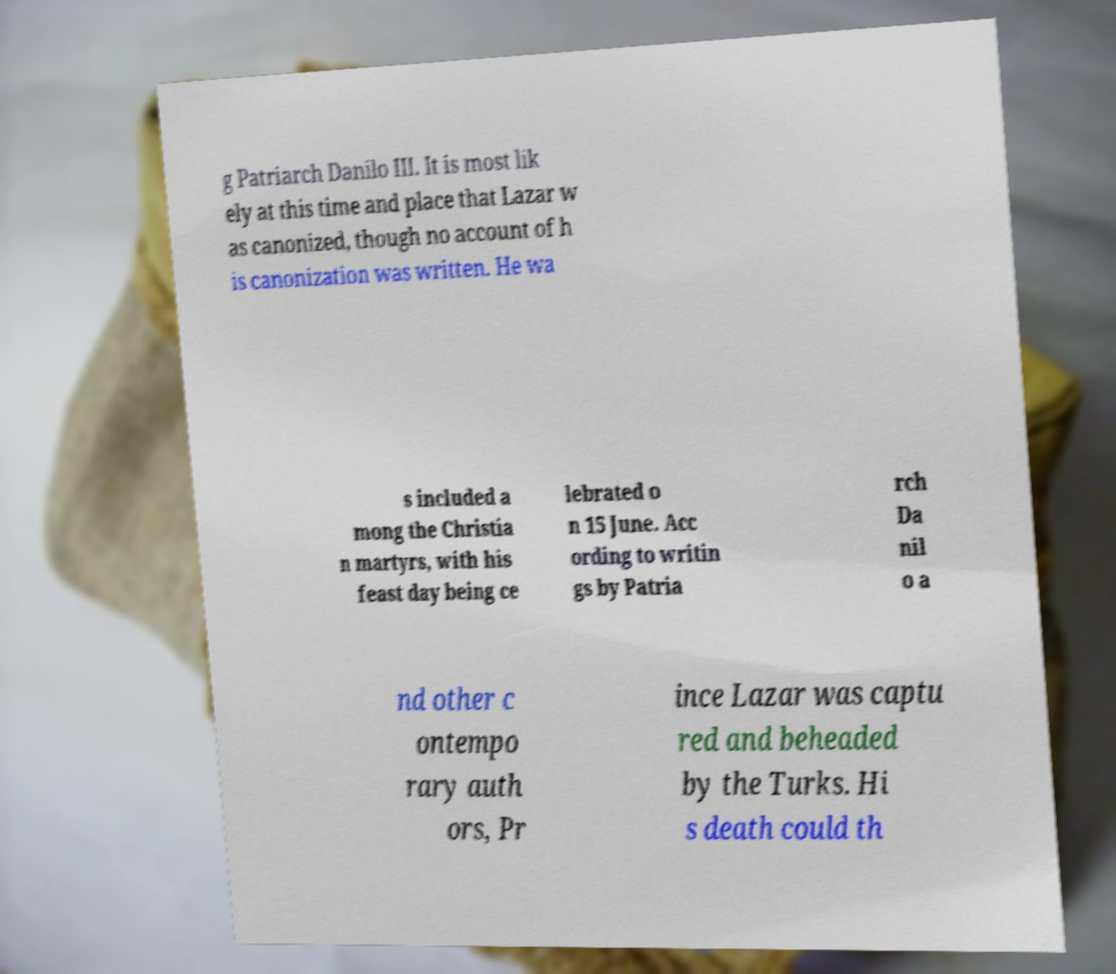Could you extract and type out the text from this image? g Patriarch Danilo III. It is most lik ely at this time and place that Lazar w as canonized, though no account of h is canonization was written. He wa s included a mong the Christia n martyrs, with his feast day being ce lebrated o n 15 June. Acc ording to writin gs by Patria rch Da nil o a nd other c ontempo rary auth ors, Pr ince Lazar was captu red and beheaded by the Turks. Hi s death could th 